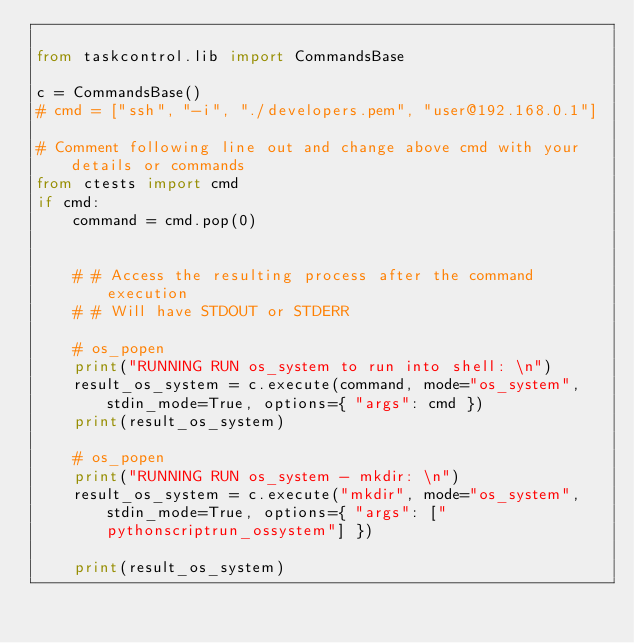<code> <loc_0><loc_0><loc_500><loc_500><_Python_>
from taskcontrol.lib import CommandsBase

c = CommandsBase()
# cmd = ["ssh", "-i", "./developers.pem", "user@192.168.0.1"]

# Comment following line out and change above cmd with your details or commands
from ctests import cmd
if cmd:
    command = cmd.pop(0)


    # # Access the resulting process after the command execution
    # # Will have STDOUT or STDERR

    # os_popen
    print("RUNNING RUN os_system to run into shell: \n")
    result_os_system = c.execute(command, mode="os_system", stdin_mode=True, options={ "args": cmd })
    print(result_os_system)

    # os_popen
    print("RUNNING RUN os_system - mkdir: \n")
    result_os_system = c.execute("mkdir", mode="os_system", stdin_mode=True, options={ "args": ["pythonscriptrun_ossystem"] })
    
    print(result_os_system)
</code> 